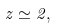Convert formula to latex. <formula><loc_0><loc_0><loc_500><loc_500>z \simeq 2 ,</formula> 